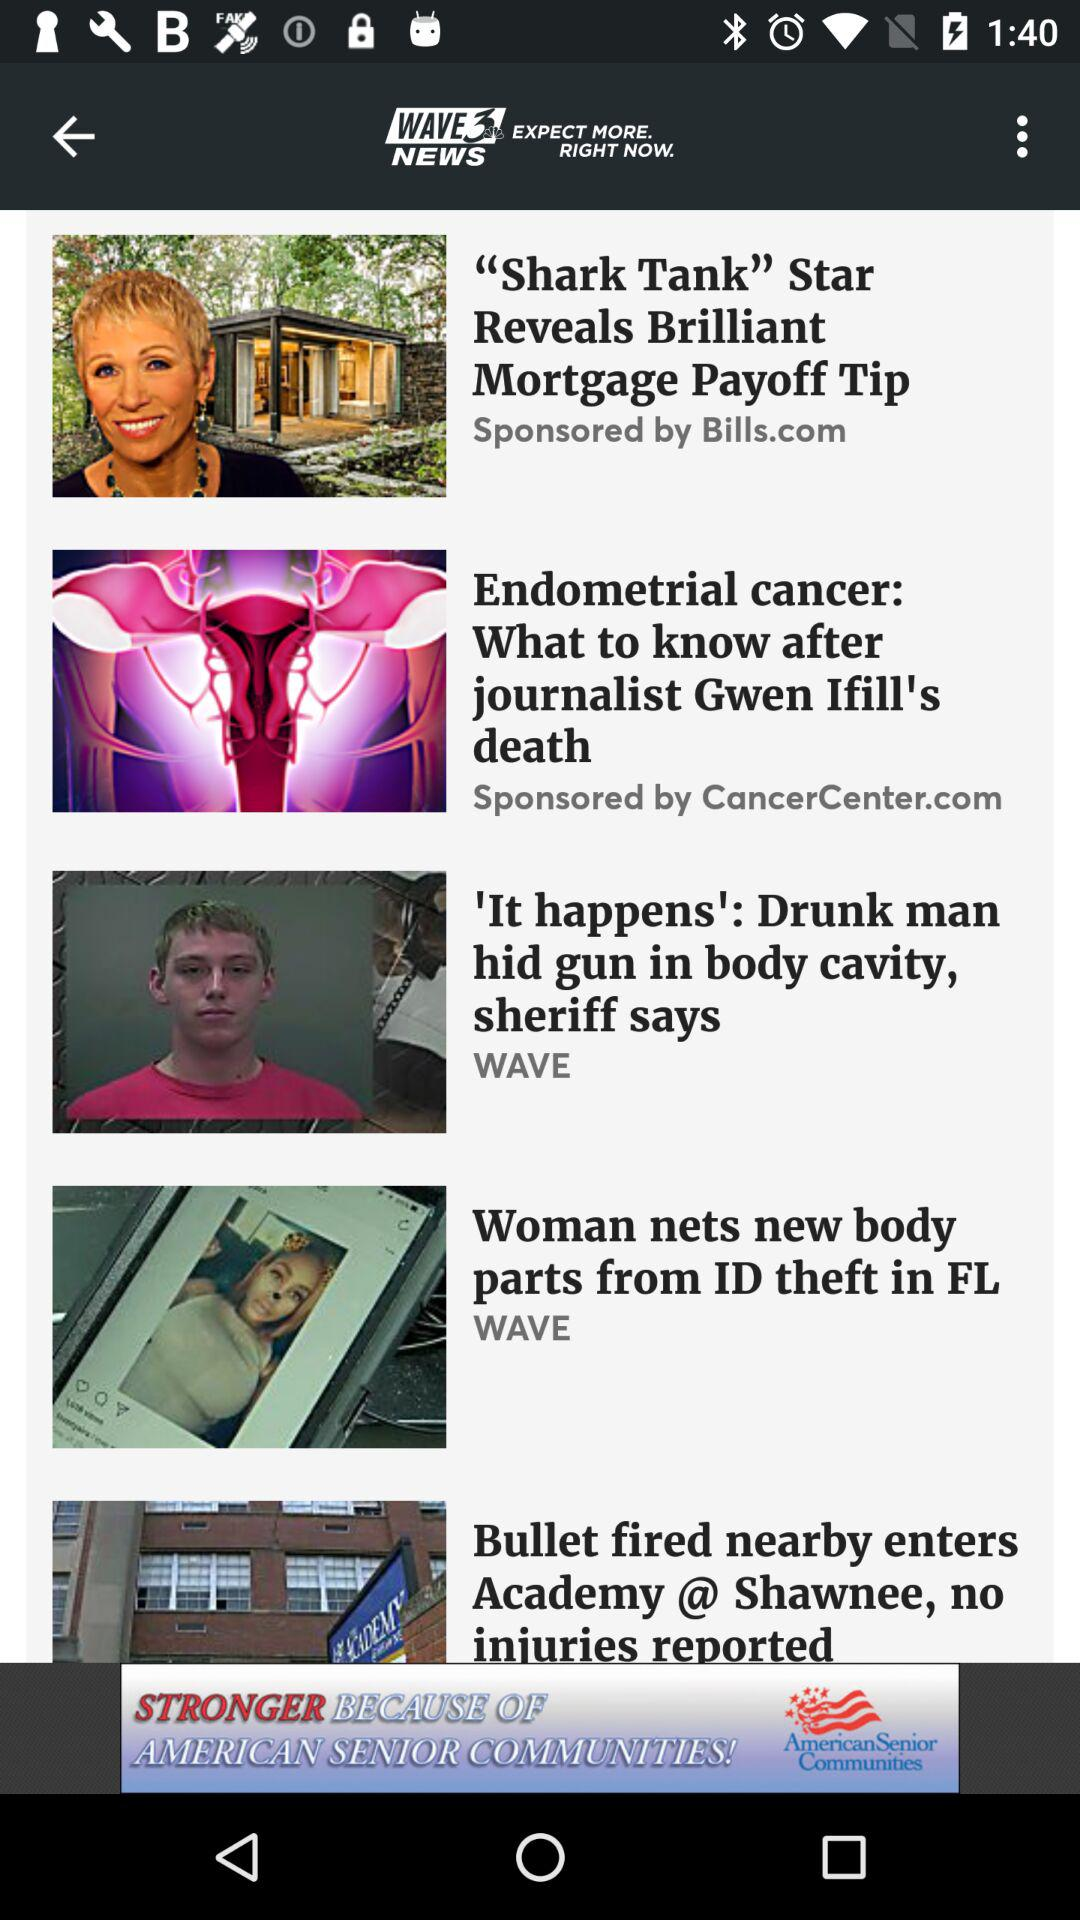What is the name of the news channel? The news channel name is "WAVE3 NEWS". 